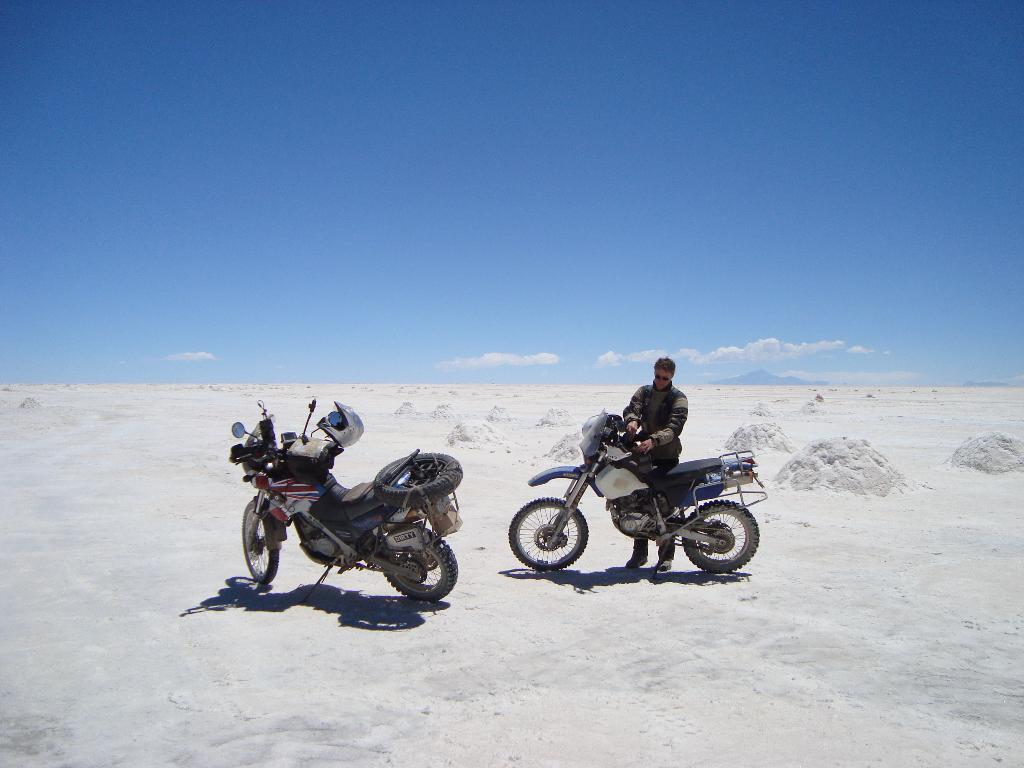What is the person in the image doing? The person is standing in front of a bike. How many bikes are visible in the image? There are two bikes in the image. Where are the bikes located? The bikes are on the sand. What can be seen in the background of the image? There are clouds and a blue sky in the background of the image. What type of seed is the person planting in the image? There is no seed or planting activity present in the image. Who is the partner of the person standing in front of the bike? There is no partner or indication of a relationship in the image. 